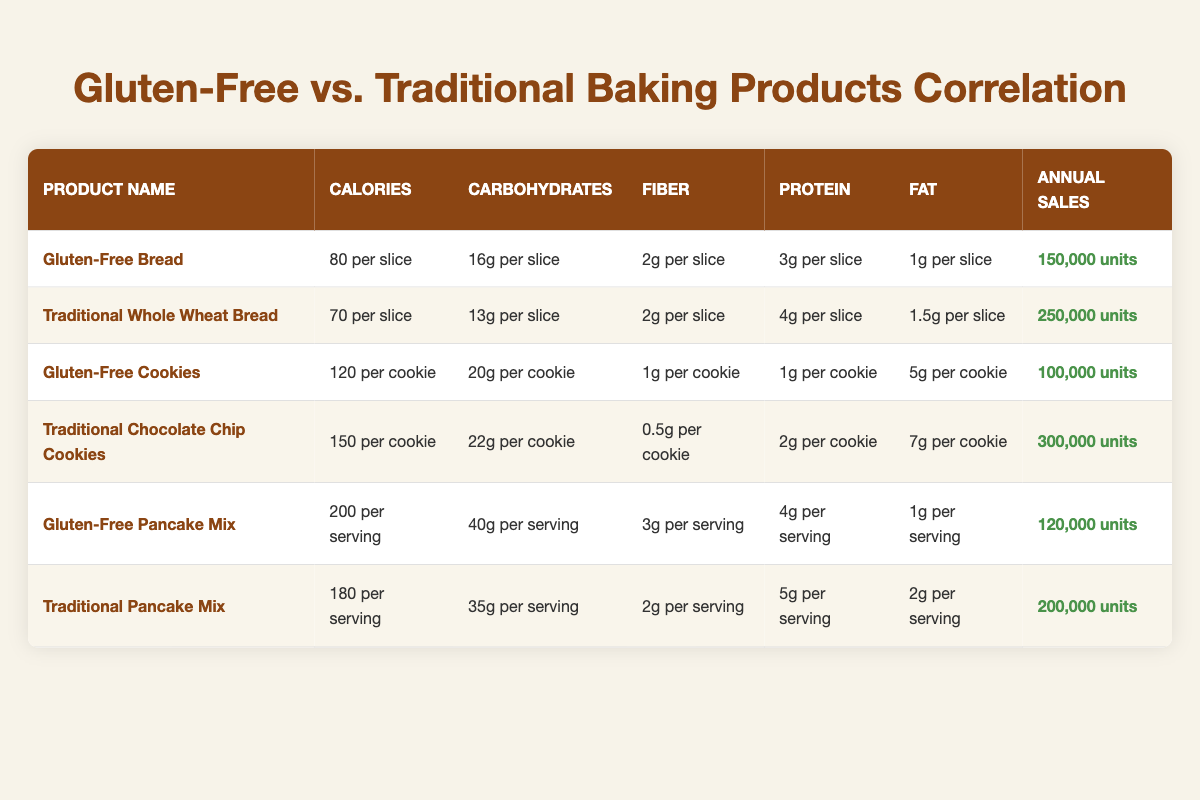What is the annual sales figure for Traditional Whole Wheat Bread? The annual sales figure for Traditional Whole Wheat Bread is directly listed in the table, showing it as 250,000 units.
Answer: 250,000 units How many calories per slice does Gluten-Free Bread contain? The table provides the calorie content for Gluten-Free Bread, stating it has 80 calories per slice.
Answer: 80 calories per slice What is the total fiber content per serving for both Gluten-Free Pancake Mix and Traditional Pancake Mix? To find the total fiber content, add the fiber content of both products: Gluten-Free Pancake Mix has 3g and Traditional Pancake Mix has 2g, so 3g + 2g = 5g.
Answer: 5g Is the protein content in Gluten-Free Cookies higher than in Traditional Chocolate Chip Cookies? Gluten-Free Cookies have 1g of protein, while Traditional Chocolate Chip Cookies have 2g. Therefore, the protein content in Gluten-Free Cookies is not higher; it is lower.
Answer: No What is the difference in annual sales units between Traditional Chocolate Chip Cookies and Gluten-Free Cookies? Traditional Chocolate Chip Cookies sell 300,000 units and Gluten-Free Cookies sell 100,000 units. The difference can be calculated as 300,000 - 100,000 = 200,000 units.
Answer: 200,000 units Which product has the highest fat content per serving among the gluten-free options? Looking at the gluten-free products, Gluten-Free Cookies have 5g of fat per cookie and Gluten-Free Pancake Mix has 1g of fat per serving. Since 5g is greater than 1g, Gluten-Free Cookies have the highest fat content.
Answer: Gluten-Free Cookies What percentage of annual sales do Traditional Pancake Mix units represent compared to all listed products? To calculate the percentage, first find the total annual sales for all products: 150,000 + 250,000 + 100,000 + 300,000 + 120,000 + 200,000 = 1,120,000 units. Traditional Pancake Mix sells 200,000 units, so the percentage is (200,000 / 1,120,000) * 100 = 17.86%.
Answer: 17.86% How many grams of carbohydrates does Gluten-Free Bread have compared to Traditional Whole Wheat Bread? Gluten-Free Bread has 16g of carbohydrates per slice while Traditional Whole Wheat Bread has 13g. Comparing both, Gluten-Free Bread has more carbohydrates by 16g - 13g = 3g.
Answer: More by 3g Does Traditional Whole Wheat Bread contain more fiber than Gluten-Free Bread? Both Gluten-Free and Traditional Whole Wheat Bread contain 2g of fiber each per slice. Therefore, Traditional Whole Wheat Bread does not contain more fiber than Gluten-Free Bread; it is equal.
Answer: No 